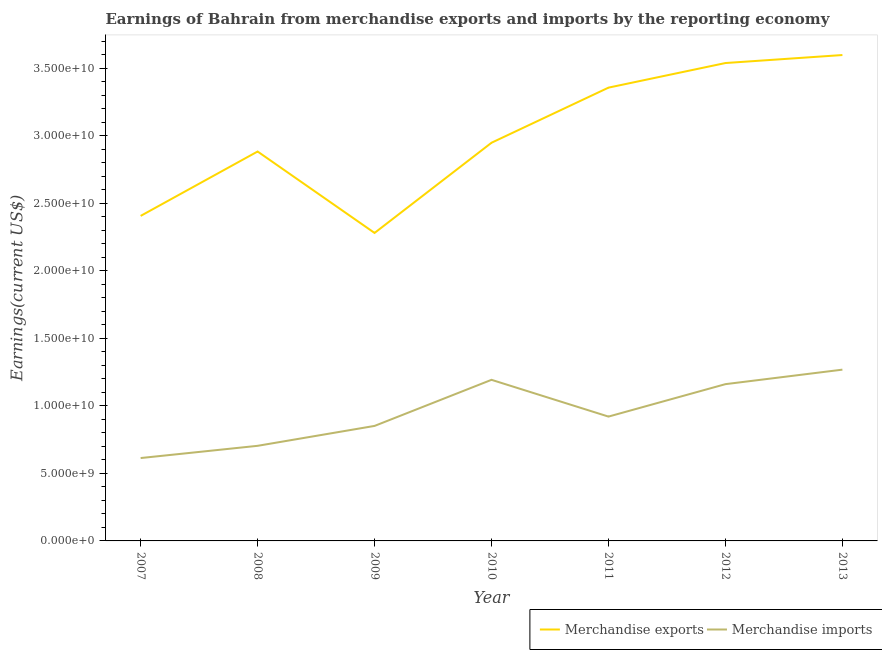Does the line corresponding to earnings from merchandise imports intersect with the line corresponding to earnings from merchandise exports?
Give a very brief answer. No. What is the earnings from merchandise exports in 2011?
Ensure brevity in your answer.  3.36e+1. Across all years, what is the maximum earnings from merchandise imports?
Make the answer very short. 1.27e+1. Across all years, what is the minimum earnings from merchandise imports?
Make the answer very short. 6.14e+09. In which year was the earnings from merchandise imports minimum?
Offer a very short reply. 2007. What is the total earnings from merchandise exports in the graph?
Your response must be concise. 2.10e+11. What is the difference between the earnings from merchandise imports in 2010 and that in 2012?
Offer a terse response. 3.20e+08. What is the difference between the earnings from merchandise imports in 2012 and the earnings from merchandise exports in 2008?
Offer a very short reply. -1.72e+1. What is the average earnings from merchandise imports per year?
Make the answer very short. 9.59e+09. In the year 2011, what is the difference between the earnings from merchandise imports and earnings from merchandise exports?
Keep it short and to the point. -2.44e+1. In how many years, is the earnings from merchandise imports greater than 26000000000 US$?
Provide a succinct answer. 0. What is the ratio of the earnings from merchandise exports in 2008 to that in 2009?
Provide a short and direct response. 1.26. What is the difference between the highest and the second highest earnings from merchandise imports?
Your answer should be compact. 7.53e+08. What is the difference between the highest and the lowest earnings from merchandise exports?
Provide a short and direct response. 1.32e+1. Is the earnings from merchandise exports strictly greater than the earnings from merchandise imports over the years?
Give a very brief answer. Yes. What is the difference between two consecutive major ticks on the Y-axis?
Your response must be concise. 5.00e+09. Are the values on the major ticks of Y-axis written in scientific E-notation?
Ensure brevity in your answer.  Yes. Does the graph contain grids?
Your answer should be very brief. No. Where does the legend appear in the graph?
Keep it short and to the point. Bottom right. How many legend labels are there?
Your answer should be very brief. 2. What is the title of the graph?
Make the answer very short. Earnings of Bahrain from merchandise exports and imports by the reporting economy. What is the label or title of the X-axis?
Provide a succinct answer. Year. What is the label or title of the Y-axis?
Provide a short and direct response. Earnings(current US$). What is the Earnings(current US$) in Merchandise exports in 2007?
Offer a terse response. 2.41e+1. What is the Earnings(current US$) of Merchandise imports in 2007?
Make the answer very short. 6.14e+09. What is the Earnings(current US$) of Merchandise exports in 2008?
Make the answer very short. 2.88e+1. What is the Earnings(current US$) of Merchandise imports in 2008?
Ensure brevity in your answer.  7.04e+09. What is the Earnings(current US$) of Merchandise exports in 2009?
Ensure brevity in your answer.  2.28e+1. What is the Earnings(current US$) in Merchandise imports in 2009?
Give a very brief answer. 8.52e+09. What is the Earnings(current US$) in Merchandise exports in 2010?
Offer a terse response. 2.95e+1. What is the Earnings(current US$) of Merchandise imports in 2010?
Offer a very short reply. 1.19e+1. What is the Earnings(current US$) in Merchandise exports in 2011?
Provide a succinct answer. 3.36e+1. What is the Earnings(current US$) in Merchandise imports in 2011?
Provide a succinct answer. 9.21e+09. What is the Earnings(current US$) of Merchandise exports in 2012?
Provide a short and direct response. 3.54e+1. What is the Earnings(current US$) in Merchandise imports in 2012?
Provide a short and direct response. 1.16e+1. What is the Earnings(current US$) in Merchandise exports in 2013?
Offer a terse response. 3.60e+1. What is the Earnings(current US$) in Merchandise imports in 2013?
Offer a terse response. 1.27e+1. Across all years, what is the maximum Earnings(current US$) of Merchandise exports?
Provide a succinct answer. 3.60e+1. Across all years, what is the maximum Earnings(current US$) in Merchandise imports?
Provide a short and direct response. 1.27e+1. Across all years, what is the minimum Earnings(current US$) in Merchandise exports?
Offer a terse response. 2.28e+1. Across all years, what is the minimum Earnings(current US$) in Merchandise imports?
Your answer should be very brief. 6.14e+09. What is the total Earnings(current US$) of Merchandise exports in the graph?
Provide a succinct answer. 2.10e+11. What is the total Earnings(current US$) of Merchandise imports in the graph?
Offer a very short reply. 6.71e+1. What is the difference between the Earnings(current US$) in Merchandise exports in 2007 and that in 2008?
Give a very brief answer. -4.77e+09. What is the difference between the Earnings(current US$) of Merchandise imports in 2007 and that in 2008?
Make the answer very short. -9.06e+08. What is the difference between the Earnings(current US$) of Merchandise exports in 2007 and that in 2009?
Your answer should be compact. 1.26e+09. What is the difference between the Earnings(current US$) in Merchandise imports in 2007 and that in 2009?
Make the answer very short. -2.38e+09. What is the difference between the Earnings(current US$) of Merchandise exports in 2007 and that in 2010?
Your answer should be compact. -5.42e+09. What is the difference between the Earnings(current US$) of Merchandise imports in 2007 and that in 2010?
Ensure brevity in your answer.  -5.79e+09. What is the difference between the Earnings(current US$) of Merchandise exports in 2007 and that in 2011?
Your answer should be compact. -9.50e+09. What is the difference between the Earnings(current US$) in Merchandise imports in 2007 and that in 2011?
Make the answer very short. -3.07e+09. What is the difference between the Earnings(current US$) in Merchandise exports in 2007 and that in 2012?
Keep it short and to the point. -1.13e+1. What is the difference between the Earnings(current US$) in Merchandise imports in 2007 and that in 2012?
Ensure brevity in your answer.  -5.47e+09. What is the difference between the Earnings(current US$) of Merchandise exports in 2007 and that in 2013?
Your answer should be compact. -1.19e+1. What is the difference between the Earnings(current US$) in Merchandise imports in 2007 and that in 2013?
Offer a very short reply. -6.55e+09. What is the difference between the Earnings(current US$) in Merchandise exports in 2008 and that in 2009?
Give a very brief answer. 6.03e+09. What is the difference between the Earnings(current US$) in Merchandise imports in 2008 and that in 2009?
Keep it short and to the point. -1.47e+09. What is the difference between the Earnings(current US$) in Merchandise exports in 2008 and that in 2010?
Your response must be concise. -6.50e+08. What is the difference between the Earnings(current US$) of Merchandise imports in 2008 and that in 2010?
Ensure brevity in your answer.  -4.89e+09. What is the difference between the Earnings(current US$) in Merchandise exports in 2008 and that in 2011?
Your answer should be very brief. -4.73e+09. What is the difference between the Earnings(current US$) of Merchandise imports in 2008 and that in 2011?
Provide a succinct answer. -2.16e+09. What is the difference between the Earnings(current US$) in Merchandise exports in 2008 and that in 2012?
Provide a short and direct response. -6.55e+09. What is the difference between the Earnings(current US$) of Merchandise imports in 2008 and that in 2012?
Give a very brief answer. -4.57e+09. What is the difference between the Earnings(current US$) of Merchandise exports in 2008 and that in 2013?
Give a very brief answer. -7.14e+09. What is the difference between the Earnings(current US$) in Merchandise imports in 2008 and that in 2013?
Ensure brevity in your answer.  -5.64e+09. What is the difference between the Earnings(current US$) in Merchandise exports in 2009 and that in 2010?
Make the answer very short. -6.68e+09. What is the difference between the Earnings(current US$) of Merchandise imports in 2009 and that in 2010?
Make the answer very short. -3.41e+09. What is the difference between the Earnings(current US$) of Merchandise exports in 2009 and that in 2011?
Your answer should be compact. -1.08e+1. What is the difference between the Earnings(current US$) of Merchandise imports in 2009 and that in 2011?
Offer a very short reply. -6.91e+08. What is the difference between the Earnings(current US$) in Merchandise exports in 2009 and that in 2012?
Make the answer very short. -1.26e+1. What is the difference between the Earnings(current US$) of Merchandise imports in 2009 and that in 2012?
Make the answer very short. -3.09e+09. What is the difference between the Earnings(current US$) of Merchandise exports in 2009 and that in 2013?
Offer a terse response. -1.32e+1. What is the difference between the Earnings(current US$) of Merchandise imports in 2009 and that in 2013?
Your response must be concise. -4.17e+09. What is the difference between the Earnings(current US$) in Merchandise exports in 2010 and that in 2011?
Your answer should be compact. -4.08e+09. What is the difference between the Earnings(current US$) in Merchandise imports in 2010 and that in 2011?
Give a very brief answer. 2.72e+09. What is the difference between the Earnings(current US$) in Merchandise exports in 2010 and that in 2012?
Provide a short and direct response. -5.90e+09. What is the difference between the Earnings(current US$) in Merchandise imports in 2010 and that in 2012?
Offer a very short reply. 3.20e+08. What is the difference between the Earnings(current US$) in Merchandise exports in 2010 and that in 2013?
Offer a very short reply. -6.49e+09. What is the difference between the Earnings(current US$) in Merchandise imports in 2010 and that in 2013?
Ensure brevity in your answer.  -7.53e+08. What is the difference between the Earnings(current US$) of Merchandise exports in 2011 and that in 2012?
Provide a short and direct response. -1.82e+09. What is the difference between the Earnings(current US$) in Merchandise imports in 2011 and that in 2012?
Your response must be concise. -2.40e+09. What is the difference between the Earnings(current US$) of Merchandise exports in 2011 and that in 2013?
Your response must be concise. -2.41e+09. What is the difference between the Earnings(current US$) of Merchandise imports in 2011 and that in 2013?
Your answer should be very brief. -3.48e+09. What is the difference between the Earnings(current US$) of Merchandise exports in 2012 and that in 2013?
Your response must be concise. -5.93e+08. What is the difference between the Earnings(current US$) in Merchandise imports in 2012 and that in 2013?
Make the answer very short. -1.07e+09. What is the difference between the Earnings(current US$) of Merchandise exports in 2007 and the Earnings(current US$) of Merchandise imports in 2008?
Offer a terse response. 1.70e+1. What is the difference between the Earnings(current US$) in Merchandise exports in 2007 and the Earnings(current US$) in Merchandise imports in 2009?
Give a very brief answer. 1.56e+1. What is the difference between the Earnings(current US$) of Merchandise exports in 2007 and the Earnings(current US$) of Merchandise imports in 2010?
Keep it short and to the point. 1.21e+1. What is the difference between the Earnings(current US$) in Merchandise exports in 2007 and the Earnings(current US$) in Merchandise imports in 2011?
Offer a very short reply. 1.49e+1. What is the difference between the Earnings(current US$) in Merchandise exports in 2007 and the Earnings(current US$) in Merchandise imports in 2012?
Your answer should be compact. 1.25e+1. What is the difference between the Earnings(current US$) of Merchandise exports in 2007 and the Earnings(current US$) of Merchandise imports in 2013?
Offer a terse response. 1.14e+1. What is the difference between the Earnings(current US$) in Merchandise exports in 2008 and the Earnings(current US$) in Merchandise imports in 2009?
Your answer should be very brief. 2.03e+1. What is the difference between the Earnings(current US$) in Merchandise exports in 2008 and the Earnings(current US$) in Merchandise imports in 2010?
Keep it short and to the point. 1.69e+1. What is the difference between the Earnings(current US$) in Merchandise exports in 2008 and the Earnings(current US$) in Merchandise imports in 2011?
Offer a very short reply. 1.96e+1. What is the difference between the Earnings(current US$) of Merchandise exports in 2008 and the Earnings(current US$) of Merchandise imports in 2012?
Provide a succinct answer. 1.72e+1. What is the difference between the Earnings(current US$) in Merchandise exports in 2008 and the Earnings(current US$) in Merchandise imports in 2013?
Provide a succinct answer. 1.62e+1. What is the difference between the Earnings(current US$) in Merchandise exports in 2009 and the Earnings(current US$) in Merchandise imports in 2010?
Offer a very short reply. 1.09e+1. What is the difference between the Earnings(current US$) of Merchandise exports in 2009 and the Earnings(current US$) of Merchandise imports in 2011?
Your answer should be very brief. 1.36e+1. What is the difference between the Earnings(current US$) in Merchandise exports in 2009 and the Earnings(current US$) in Merchandise imports in 2012?
Your answer should be compact. 1.12e+1. What is the difference between the Earnings(current US$) in Merchandise exports in 2009 and the Earnings(current US$) in Merchandise imports in 2013?
Give a very brief answer. 1.01e+1. What is the difference between the Earnings(current US$) of Merchandise exports in 2010 and the Earnings(current US$) of Merchandise imports in 2011?
Ensure brevity in your answer.  2.03e+1. What is the difference between the Earnings(current US$) in Merchandise exports in 2010 and the Earnings(current US$) in Merchandise imports in 2012?
Offer a very short reply. 1.79e+1. What is the difference between the Earnings(current US$) of Merchandise exports in 2010 and the Earnings(current US$) of Merchandise imports in 2013?
Offer a very short reply. 1.68e+1. What is the difference between the Earnings(current US$) in Merchandise exports in 2011 and the Earnings(current US$) in Merchandise imports in 2012?
Give a very brief answer. 2.20e+1. What is the difference between the Earnings(current US$) of Merchandise exports in 2011 and the Earnings(current US$) of Merchandise imports in 2013?
Provide a short and direct response. 2.09e+1. What is the difference between the Earnings(current US$) in Merchandise exports in 2012 and the Earnings(current US$) in Merchandise imports in 2013?
Your answer should be very brief. 2.27e+1. What is the average Earnings(current US$) in Merchandise exports per year?
Offer a terse response. 3.00e+1. What is the average Earnings(current US$) in Merchandise imports per year?
Keep it short and to the point. 9.59e+09. In the year 2007, what is the difference between the Earnings(current US$) of Merchandise exports and Earnings(current US$) of Merchandise imports?
Give a very brief answer. 1.79e+1. In the year 2008, what is the difference between the Earnings(current US$) in Merchandise exports and Earnings(current US$) in Merchandise imports?
Ensure brevity in your answer.  2.18e+1. In the year 2009, what is the difference between the Earnings(current US$) of Merchandise exports and Earnings(current US$) of Merchandise imports?
Keep it short and to the point. 1.43e+1. In the year 2010, what is the difference between the Earnings(current US$) in Merchandise exports and Earnings(current US$) in Merchandise imports?
Give a very brief answer. 1.76e+1. In the year 2011, what is the difference between the Earnings(current US$) of Merchandise exports and Earnings(current US$) of Merchandise imports?
Provide a succinct answer. 2.44e+1. In the year 2012, what is the difference between the Earnings(current US$) in Merchandise exports and Earnings(current US$) in Merchandise imports?
Give a very brief answer. 2.38e+1. In the year 2013, what is the difference between the Earnings(current US$) of Merchandise exports and Earnings(current US$) of Merchandise imports?
Provide a succinct answer. 2.33e+1. What is the ratio of the Earnings(current US$) of Merchandise exports in 2007 to that in 2008?
Provide a short and direct response. 0.83. What is the ratio of the Earnings(current US$) in Merchandise imports in 2007 to that in 2008?
Ensure brevity in your answer.  0.87. What is the ratio of the Earnings(current US$) in Merchandise exports in 2007 to that in 2009?
Provide a succinct answer. 1.06. What is the ratio of the Earnings(current US$) of Merchandise imports in 2007 to that in 2009?
Ensure brevity in your answer.  0.72. What is the ratio of the Earnings(current US$) in Merchandise exports in 2007 to that in 2010?
Your response must be concise. 0.82. What is the ratio of the Earnings(current US$) in Merchandise imports in 2007 to that in 2010?
Your answer should be compact. 0.51. What is the ratio of the Earnings(current US$) in Merchandise exports in 2007 to that in 2011?
Your answer should be compact. 0.72. What is the ratio of the Earnings(current US$) of Merchandise imports in 2007 to that in 2011?
Your answer should be compact. 0.67. What is the ratio of the Earnings(current US$) in Merchandise exports in 2007 to that in 2012?
Your answer should be very brief. 0.68. What is the ratio of the Earnings(current US$) in Merchandise imports in 2007 to that in 2012?
Keep it short and to the point. 0.53. What is the ratio of the Earnings(current US$) in Merchandise exports in 2007 to that in 2013?
Keep it short and to the point. 0.67. What is the ratio of the Earnings(current US$) in Merchandise imports in 2007 to that in 2013?
Offer a very short reply. 0.48. What is the ratio of the Earnings(current US$) of Merchandise exports in 2008 to that in 2009?
Ensure brevity in your answer.  1.26. What is the ratio of the Earnings(current US$) of Merchandise imports in 2008 to that in 2009?
Make the answer very short. 0.83. What is the ratio of the Earnings(current US$) of Merchandise exports in 2008 to that in 2010?
Your response must be concise. 0.98. What is the ratio of the Earnings(current US$) of Merchandise imports in 2008 to that in 2010?
Provide a short and direct response. 0.59. What is the ratio of the Earnings(current US$) of Merchandise exports in 2008 to that in 2011?
Your answer should be very brief. 0.86. What is the ratio of the Earnings(current US$) in Merchandise imports in 2008 to that in 2011?
Your response must be concise. 0.76. What is the ratio of the Earnings(current US$) in Merchandise exports in 2008 to that in 2012?
Make the answer very short. 0.81. What is the ratio of the Earnings(current US$) of Merchandise imports in 2008 to that in 2012?
Give a very brief answer. 0.61. What is the ratio of the Earnings(current US$) of Merchandise exports in 2008 to that in 2013?
Keep it short and to the point. 0.8. What is the ratio of the Earnings(current US$) of Merchandise imports in 2008 to that in 2013?
Your response must be concise. 0.56. What is the ratio of the Earnings(current US$) in Merchandise exports in 2009 to that in 2010?
Your response must be concise. 0.77. What is the ratio of the Earnings(current US$) in Merchandise imports in 2009 to that in 2010?
Provide a short and direct response. 0.71. What is the ratio of the Earnings(current US$) in Merchandise exports in 2009 to that in 2011?
Make the answer very short. 0.68. What is the ratio of the Earnings(current US$) of Merchandise imports in 2009 to that in 2011?
Provide a succinct answer. 0.93. What is the ratio of the Earnings(current US$) in Merchandise exports in 2009 to that in 2012?
Give a very brief answer. 0.64. What is the ratio of the Earnings(current US$) in Merchandise imports in 2009 to that in 2012?
Your response must be concise. 0.73. What is the ratio of the Earnings(current US$) in Merchandise exports in 2009 to that in 2013?
Offer a terse response. 0.63. What is the ratio of the Earnings(current US$) of Merchandise imports in 2009 to that in 2013?
Provide a succinct answer. 0.67. What is the ratio of the Earnings(current US$) of Merchandise exports in 2010 to that in 2011?
Provide a succinct answer. 0.88. What is the ratio of the Earnings(current US$) in Merchandise imports in 2010 to that in 2011?
Provide a short and direct response. 1.3. What is the ratio of the Earnings(current US$) of Merchandise exports in 2010 to that in 2012?
Your answer should be compact. 0.83. What is the ratio of the Earnings(current US$) in Merchandise imports in 2010 to that in 2012?
Your answer should be compact. 1.03. What is the ratio of the Earnings(current US$) in Merchandise exports in 2010 to that in 2013?
Your answer should be very brief. 0.82. What is the ratio of the Earnings(current US$) in Merchandise imports in 2010 to that in 2013?
Provide a succinct answer. 0.94. What is the ratio of the Earnings(current US$) in Merchandise exports in 2011 to that in 2012?
Your answer should be compact. 0.95. What is the ratio of the Earnings(current US$) in Merchandise imports in 2011 to that in 2012?
Ensure brevity in your answer.  0.79. What is the ratio of the Earnings(current US$) in Merchandise exports in 2011 to that in 2013?
Give a very brief answer. 0.93. What is the ratio of the Earnings(current US$) in Merchandise imports in 2011 to that in 2013?
Provide a short and direct response. 0.73. What is the ratio of the Earnings(current US$) of Merchandise exports in 2012 to that in 2013?
Offer a very short reply. 0.98. What is the ratio of the Earnings(current US$) in Merchandise imports in 2012 to that in 2013?
Your answer should be compact. 0.92. What is the difference between the highest and the second highest Earnings(current US$) in Merchandise exports?
Provide a succinct answer. 5.93e+08. What is the difference between the highest and the second highest Earnings(current US$) in Merchandise imports?
Your answer should be compact. 7.53e+08. What is the difference between the highest and the lowest Earnings(current US$) in Merchandise exports?
Offer a terse response. 1.32e+1. What is the difference between the highest and the lowest Earnings(current US$) of Merchandise imports?
Offer a very short reply. 6.55e+09. 